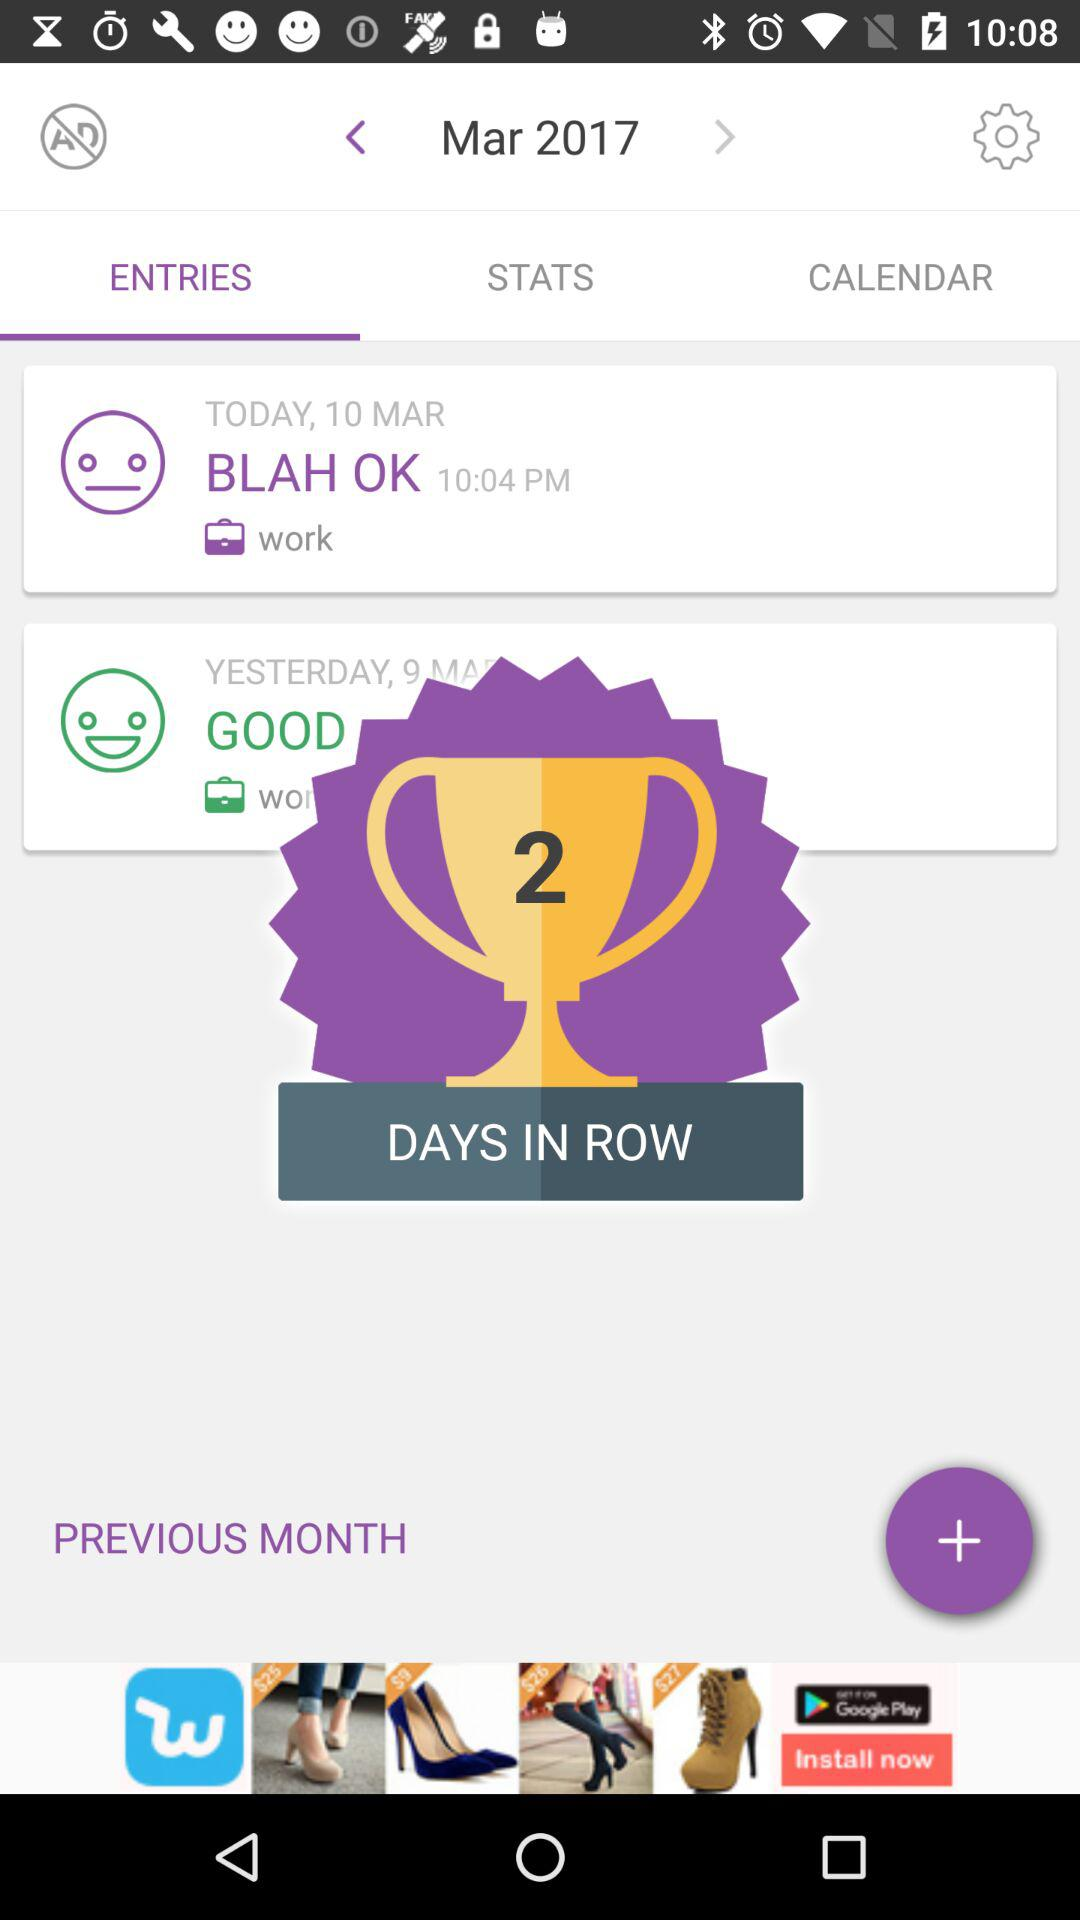What is the selected month? The selected month is March. 